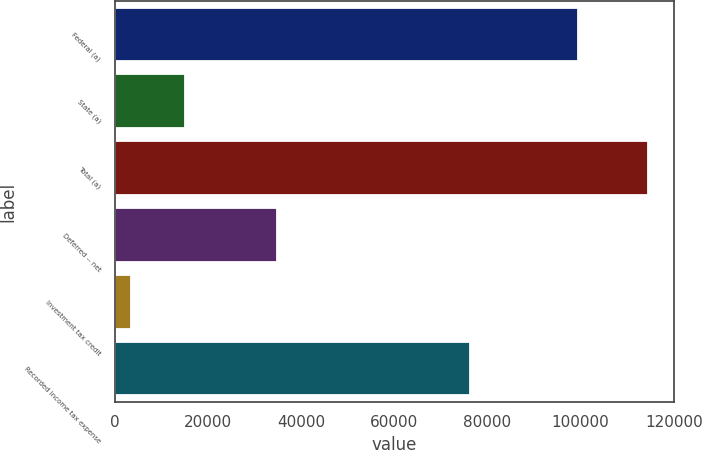Convert chart to OTSL. <chart><loc_0><loc_0><loc_500><loc_500><bar_chart><fcel>Federal (a)<fcel>State (a)<fcel>Total (a)<fcel>Deferred -- net<fcel>Investment tax credit<fcel>Recorded income tax expense<nl><fcel>99429<fcel>14994<fcel>114423<fcel>34770<fcel>3476<fcel>76177<nl></chart> 